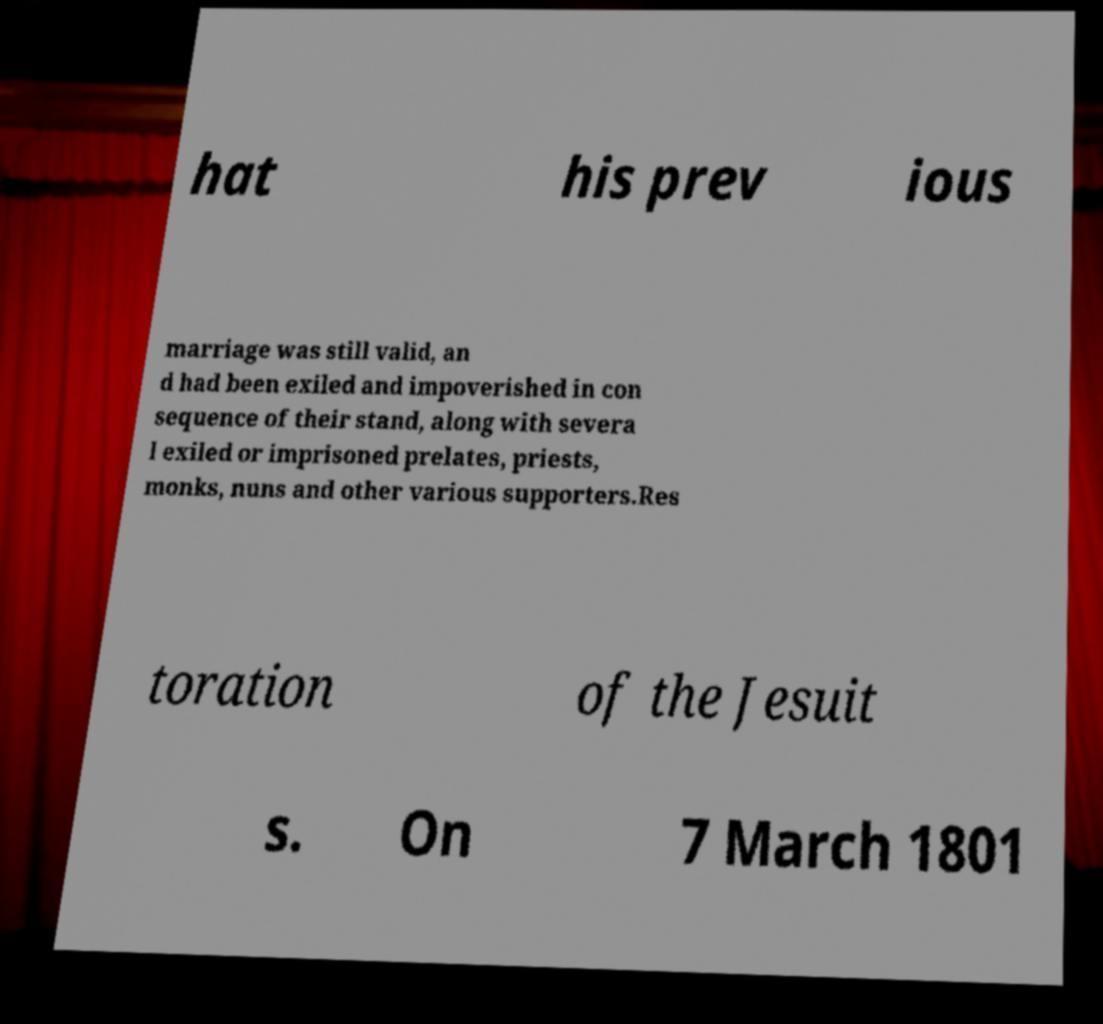Could you assist in decoding the text presented in this image and type it out clearly? hat his prev ious marriage was still valid, an d had been exiled and impoverished in con sequence of their stand, along with severa l exiled or imprisoned prelates, priests, monks, nuns and other various supporters.Res toration of the Jesuit s. On 7 March 1801 